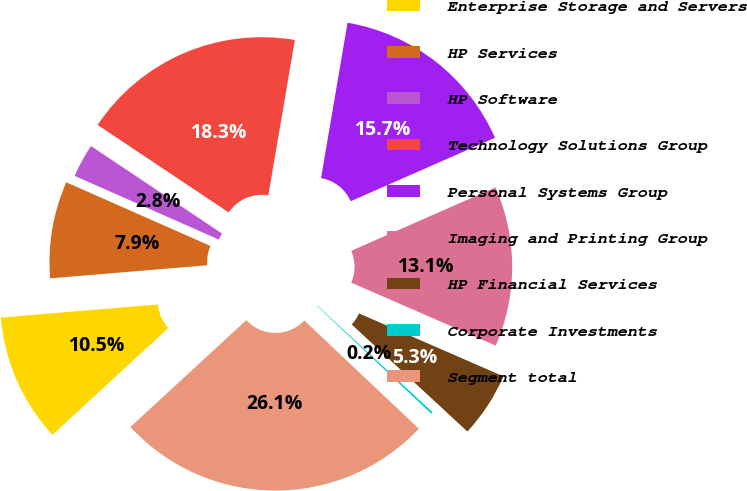Convert chart to OTSL. <chart><loc_0><loc_0><loc_500><loc_500><pie_chart><fcel>Enterprise Storage and Servers<fcel>HP Services<fcel>HP Software<fcel>Technology Solutions Group<fcel>Personal Systems Group<fcel>Imaging and Printing Group<fcel>HP Financial Services<fcel>Corporate Investments<fcel>Segment total<nl><fcel>10.53%<fcel>7.94%<fcel>2.75%<fcel>18.32%<fcel>15.72%<fcel>13.13%<fcel>5.34%<fcel>0.16%<fcel>26.1%<nl></chart> 